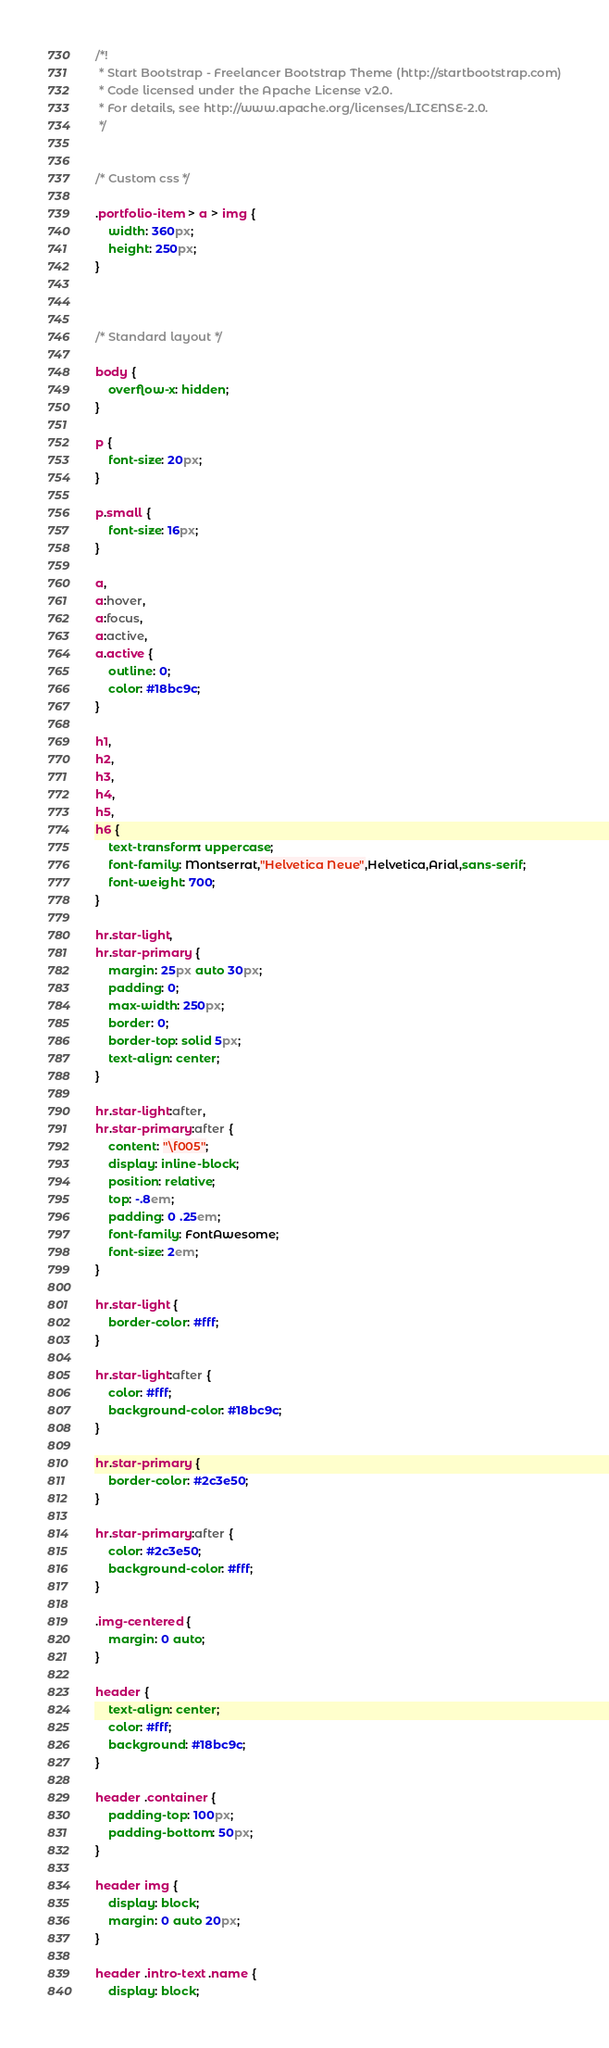<code> <loc_0><loc_0><loc_500><loc_500><_CSS_>/*!
 * Start Bootstrap - Freelancer Bootstrap Theme (http://startbootstrap.com)
 * Code licensed under the Apache License v2.0.
 * For details, see http://www.apache.org/licenses/LICENSE-2.0.
 */


/* Custom css */

.portfolio-item > a > img {
    width: 360px;
    height: 250px;
}



/* Standard layout */

body {
    overflow-x: hidden;
}

p {
    font-size: 20px;
}

p.small {
    font-size: 16px;
}

a,
a:hover,
a:focus,
a:active,
a.active {
    outline: 0;
    color: #18bc9c;
}

h1,
h2,
h3,
h4,
h5,
h6 {
    text-transform: uppercase;
    font-family: Montserrat,"Helvetica Neue",Helvetica,Arial,sans-serif;
    font-weight: 700;
}

hr.star-light,
hr.star-primary {
    margin: 25px auto 30px;
    padding: 0;
    max-width: 250px;
    border: 0;
    border-top: solid 5px;
    text-align: center;
}

hr.star-light:after,
hr.star-primary:after {
    content: "\f005";
    display: inline-block;
    position: relative;
    top: -.8em;
    padding: 0 .25em;
    font-family: FontAwesome;
    font-size: 2em;
}

hr.star-light {
    border-color: #fff;
}

hr.star-light:after {
    color: #fff;
    background-color: #18bc9c;
}

hr.star-primary {
    border-color: #2c3e50;
}

hr.star-primary:after {
    color: #2c3e50;
    background-color: #fff;
}

.img-centered {
    margin: 0 auto;
}

header {
    text-align: center;
    color: #fff;
    background: #18bc9c;
}

header .container {
    padding-top: 100px;
    padding-bottom: 50px;
}

header img {
    display: block;
    margin: 0 auto 20px;
}

header .intro-text .name {
    display: block;</code> 